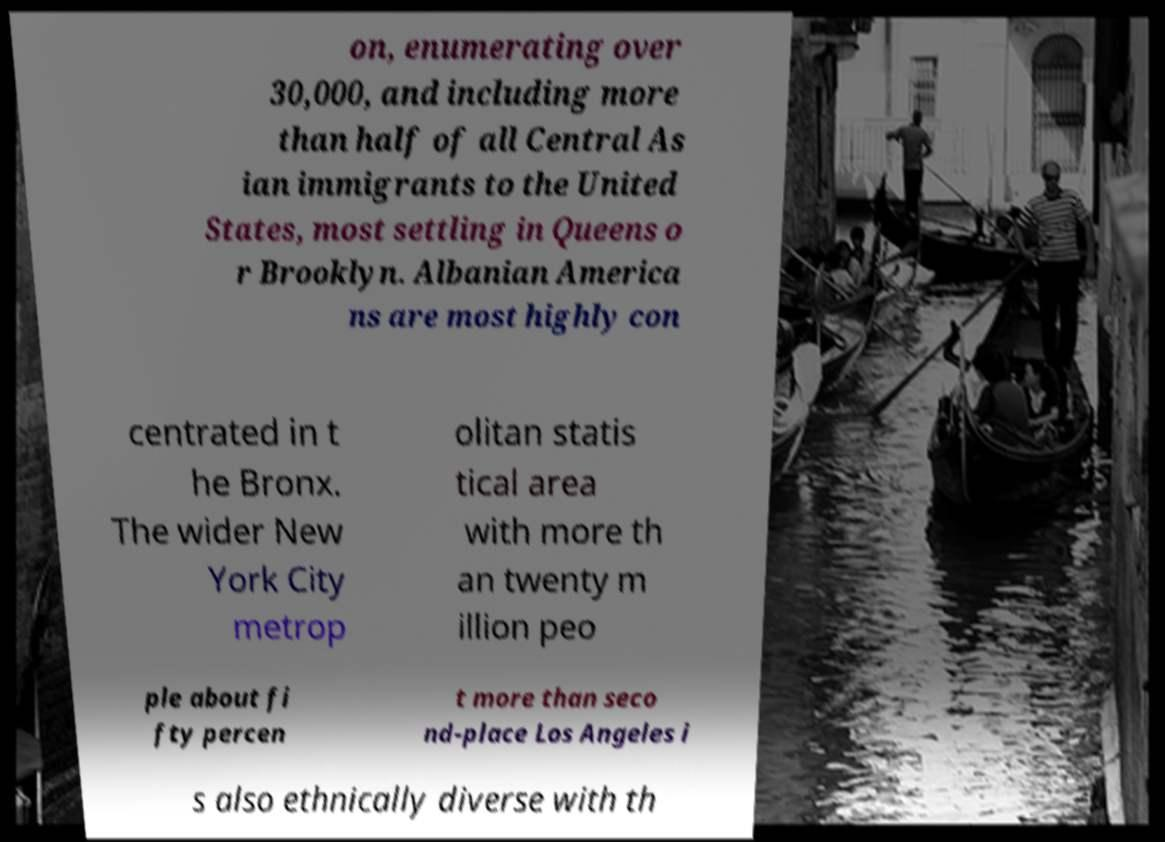For documentation purposes, I need the text within this image transcribed. Could you provide that? on, enumerating over 30,000, and including more than half of all Central As ian immigrants to the United States, most settling in Queens o r Brooklyn. Albanian America ns are most highly con centrated in t he Bronx. The wider New York City metrop olitan statis tical area with more th an twenty m illion peo ple about fi fty percen t more than seco nd-place Los Angeles i s also ethnically diverse with th 